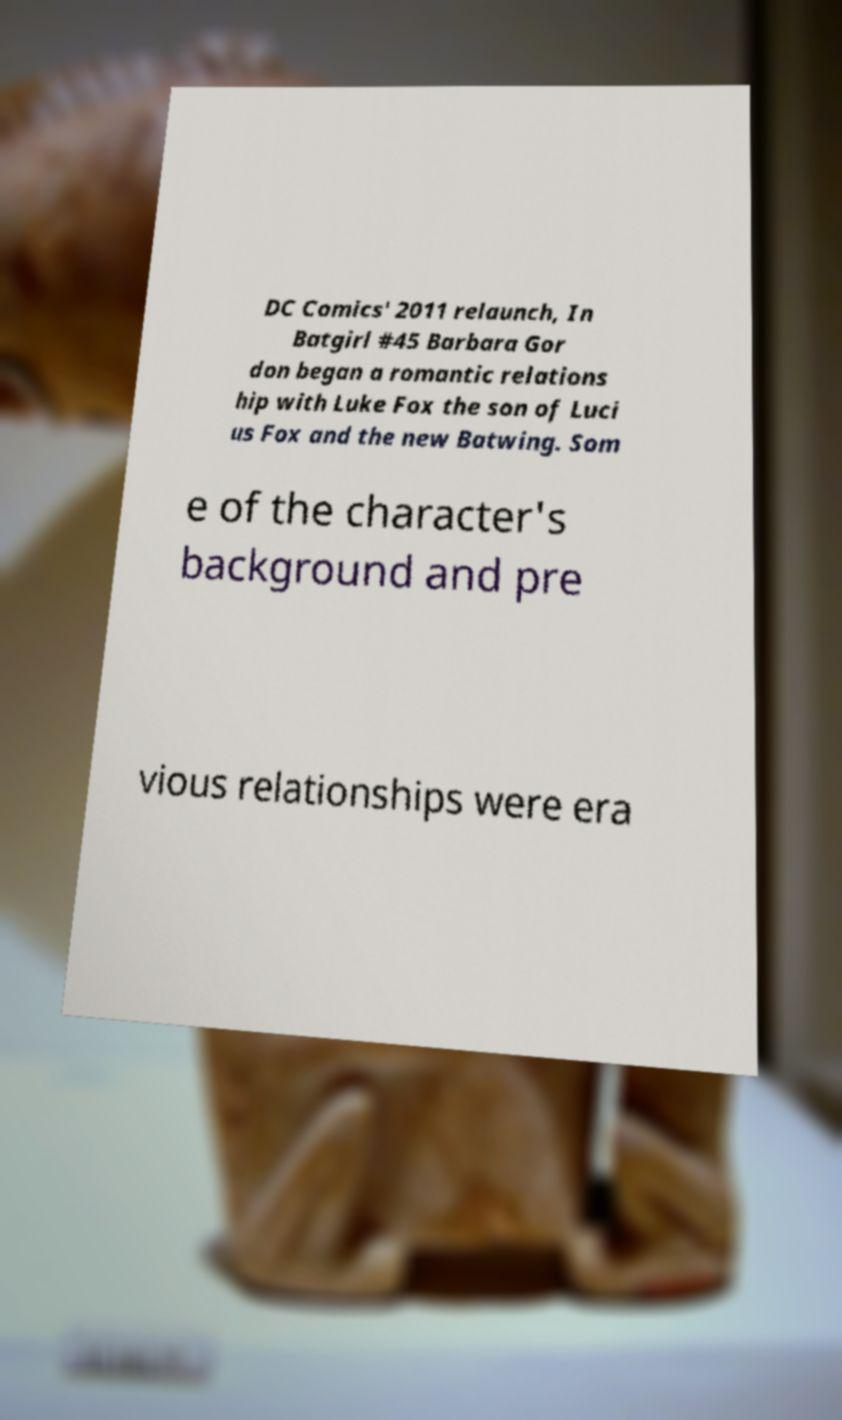There's text embedded in this image that I need extracted. Can you transcribe it verbatim? DC Comics' 2011 relaunch, In Batgirl #45 Barbara Gor don began a romantic relations hip with Luke Fox the son of Luci us Fox and the new Batwing. Som e of the character's background and pre vious relationships were era 